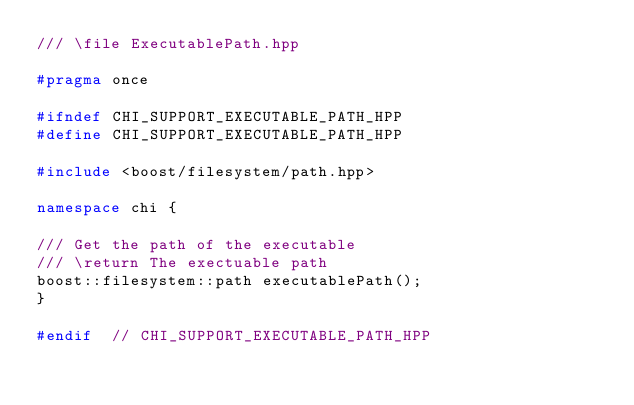<code> <loc_0><loc_0><loc_500><loc_500><_C++_>/// \file ExecutablePath.hpp

#pragma once

#ifndef CHI_SUPPORT_EXECUTABLE_PATH_HPP
#define CHI_SUPPORT_EXECUTABLE_PATH_HPP

#include <boost/filesystem/path.hpp>

namespace chi {

/// Get the path of the executable
/// \return The exectuable path
boost::filesystem::path executablePath();
}

#endif  // CHI_SUPPORT_EXECUTABLE_PATH_HPP
</code> 